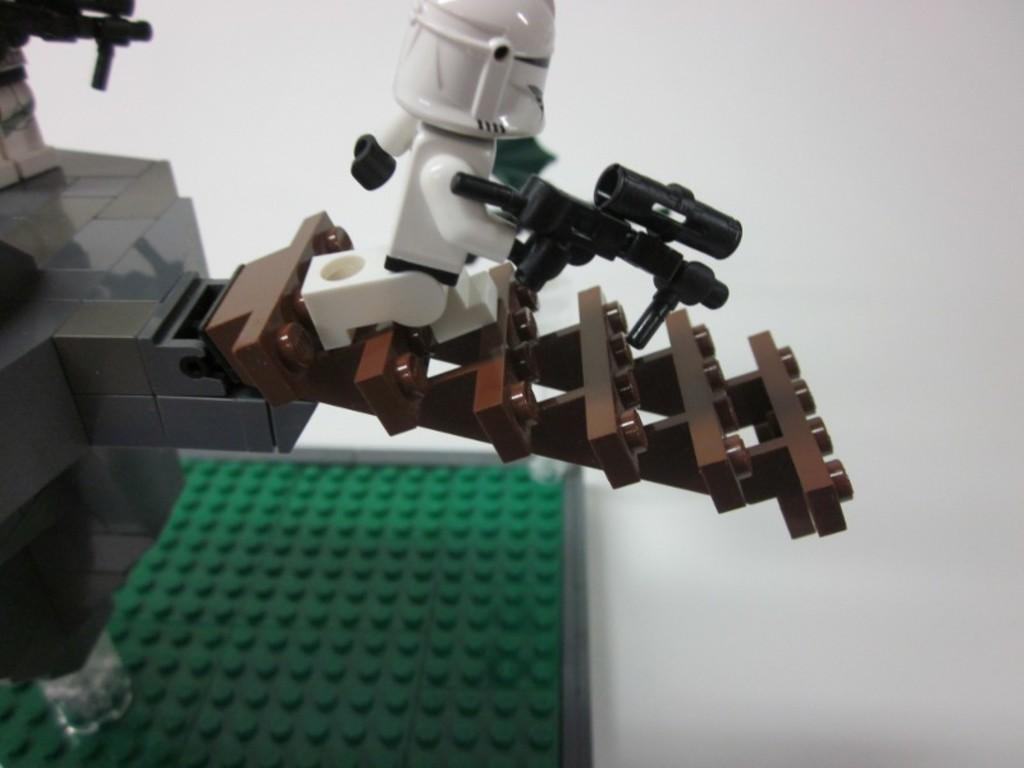What type of toy is in the image? There is a robot toy in the image. What is the robot toy placed on? The robot toy is on a lego building. Where are the robot toy and the lego building located? Both the robot toy and the lego building are on a table. How much development has been achieved in the robot toy's programming? The image does not provide any information about the robot toy's programming or development, so it cannot be determined from the image. 